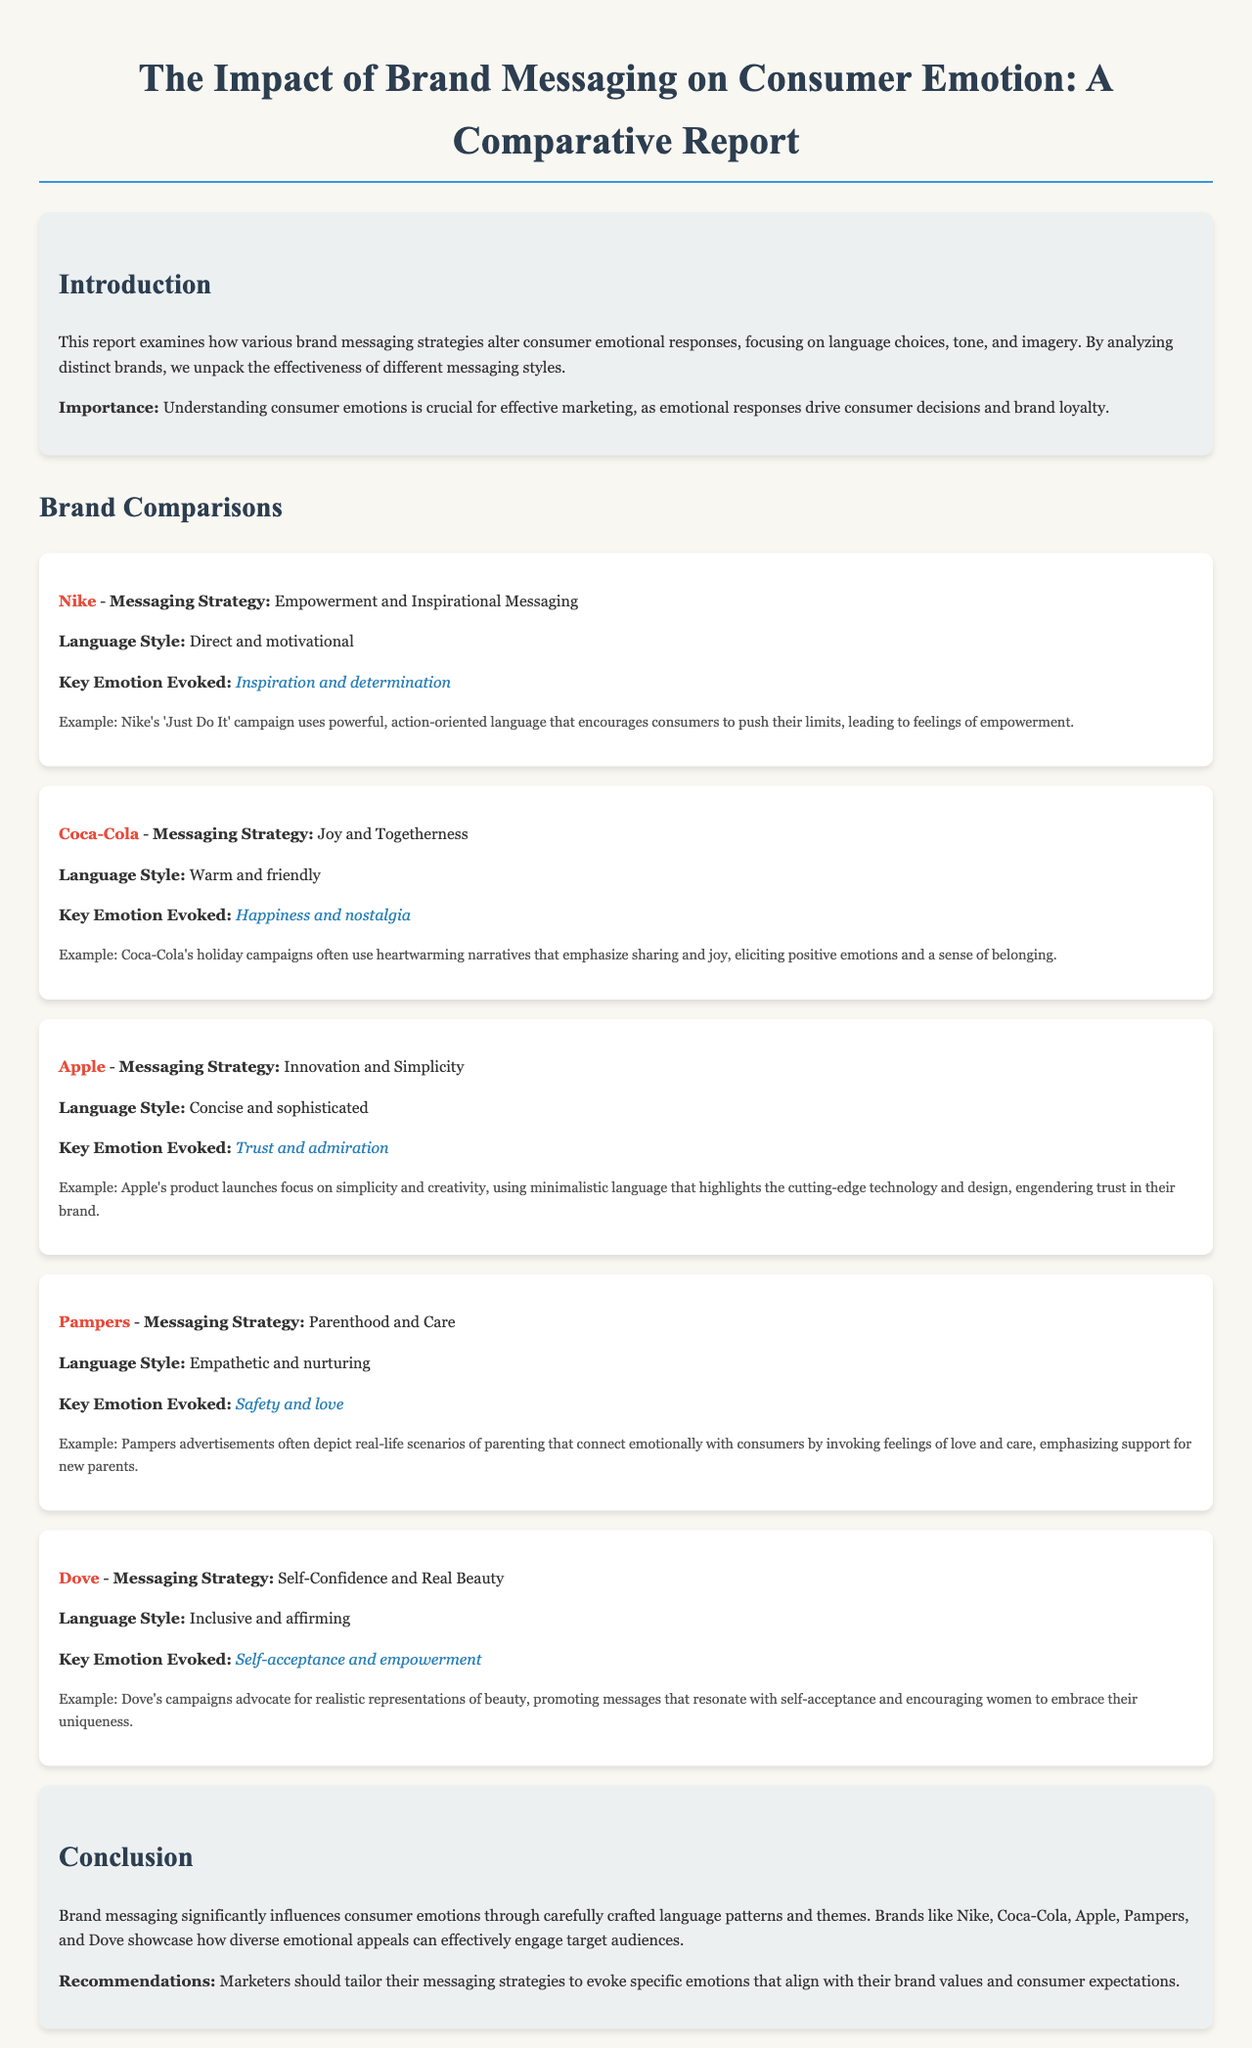What is the main focus of the report? The report focuses on how various brand messaging strategies alter consumer emotional responses, focusing on language choices, tone, and imagery.
Answer: Brand messaging strategies Which brand is associated with the messaging strategy of Empowerment? The document states that Nike employs an Empowerment and Inspirational Messaging strategy.
Answer: Nike What key emotion does Coca-Cola evoke through its messaging? The report indicates that Coca-Cola’s key emotion evoked is Happiness and nostalgia.
Answer: Happiness and nostalgia What language style does Pampers use in their messaging? Pampers is described as using an Empathetic and nurturing language style.
Answer: Empathetic and nurturing What recommendation is given to marketers in the conclusion? The conclusion suggests that marketers should tailor their messaging strategies to evoke specific emotions that align with their brand values.
Answer: Tailor their messaging strategies What is the example of Nike's campaign mentioned? The report provides an example of Nike's 'Just Do It' campaign as using powerful, action-oriented language.
Answer: 'Just Do It' campaign Which brand's strategy emphasizes Real Beauty? Dove's messaging strategy focuses on Self-Confidence and Real Beauty.
Answer: Dove How does Apple’s messaging style contribute to consumer emotions? Apple uses a Concise and sophisticated language style that engenders trust in their brand.
Answer: Engenders trust 